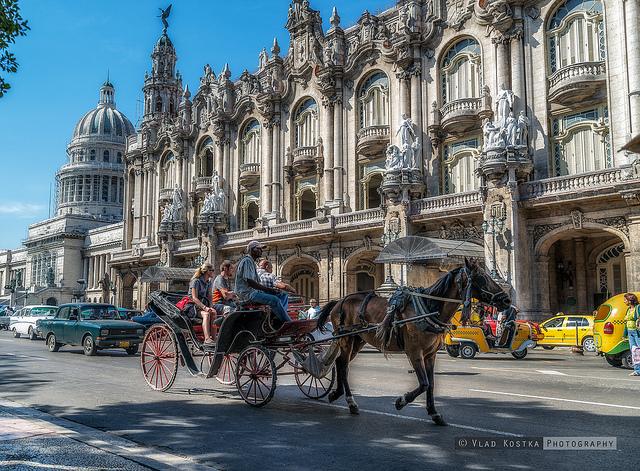What is pulling the carriage?
Concise answer only. Horse. Are these buildings of modern architecture?
Give a very brief answer. No. Are all the modes of transportation in this image cars?
Answer briefly. No. 